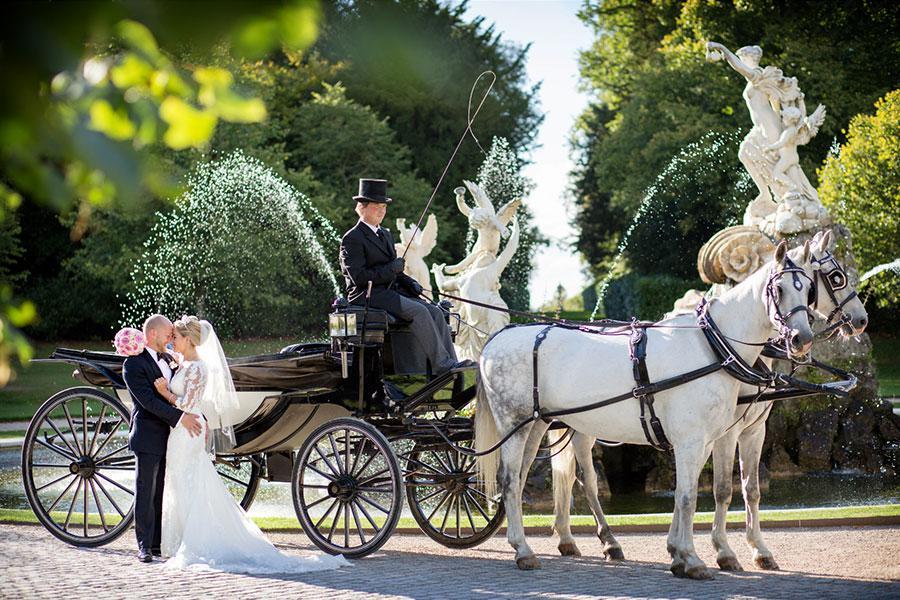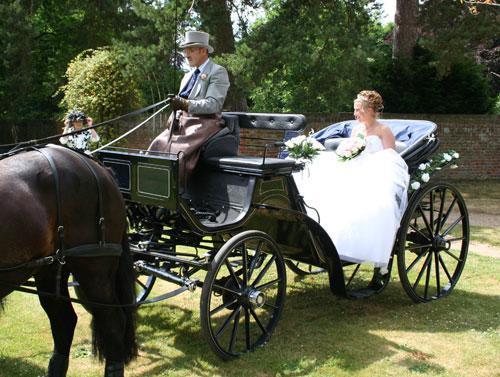The first image is the image on the left, the second image is the image on the right. Considering the images on both sides, is "Nine or more mammals are visible." valid? Answer yes or no. Yes. 